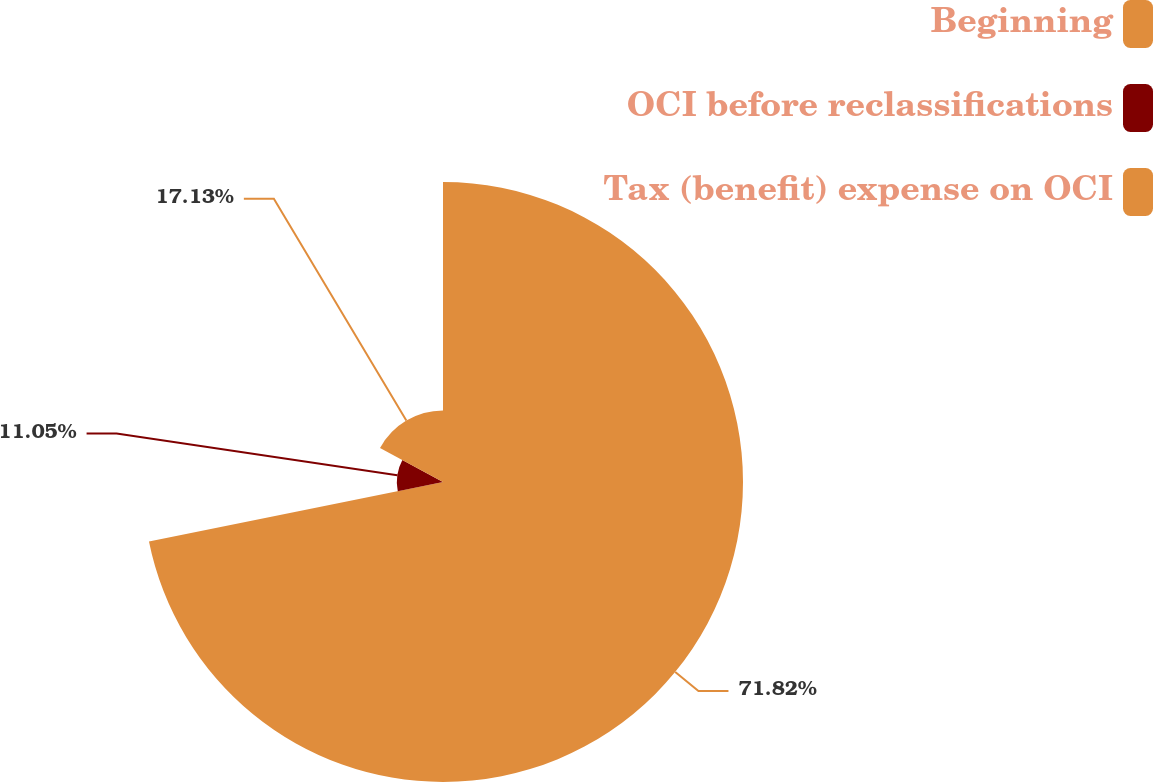<chart> <loc_0><loc_0><loc_500><loc_500><pie_chart><fcel>Beginning<fcel>OCI before reclassifications<fcel>Tax (benefit) expense on OCI<nl><fcel>71.82%<fcel>11.05%<fcel>17.13%<nl></chart> 